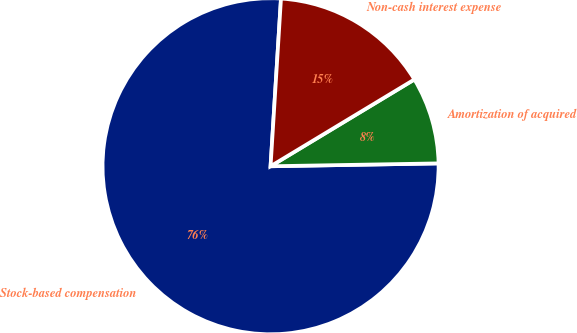Convert chart. <chart><loc_0><loc_0><loc_500><loc_500><pie_chart><fcel>Stock-based compensation<fcel>Amortization of acquired<fcel>Non-cash interest expense<nl><fcel>76.26%<fcel>8.37%<fcel>15.37%<nl></chart> 